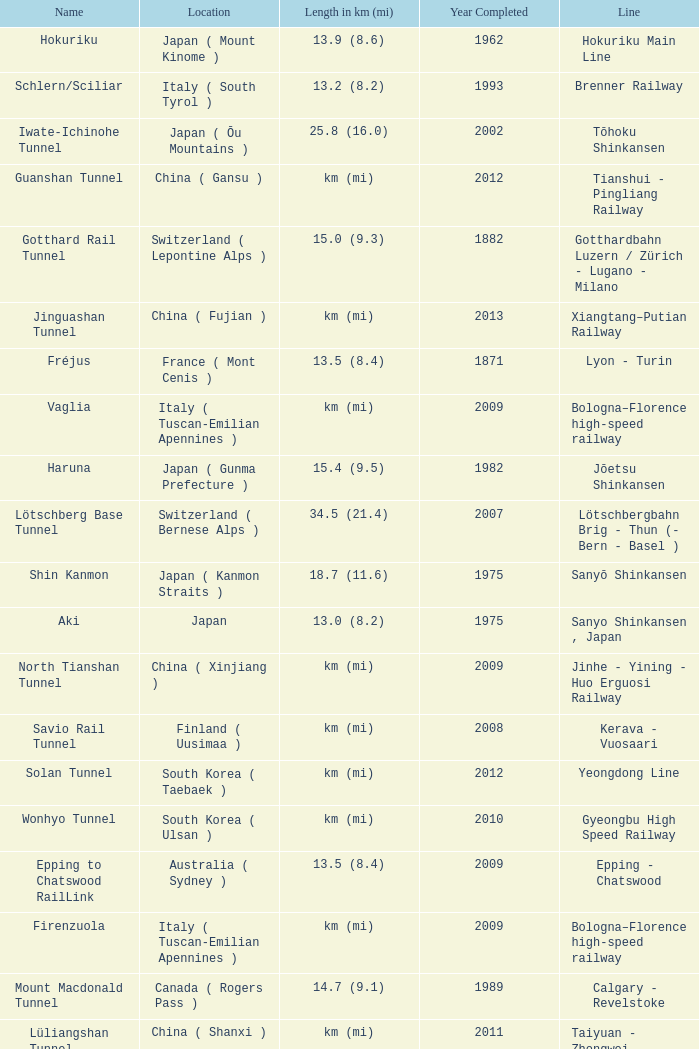Which line is the Geumjeong tunnel? Gyeongbu High Speed Railway. 